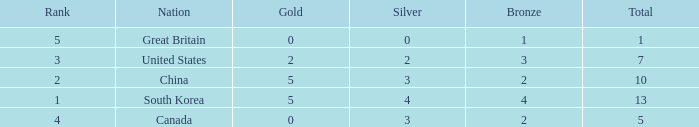What is the lowest Rank, when Nation is Great Britain, and when Bronze is less than 1? None. 